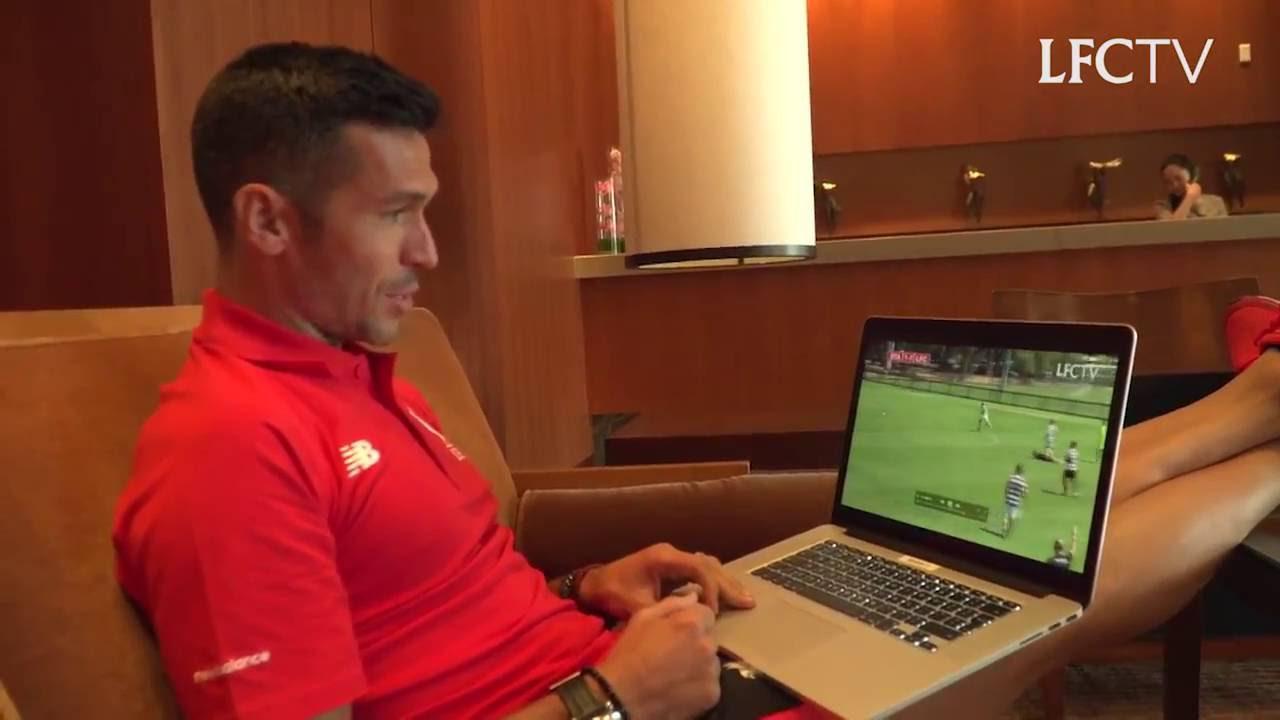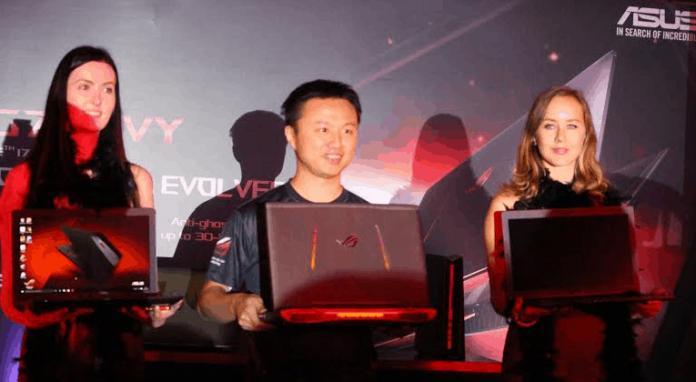The first image is the image on the left, the second image is the image on the right. Considering the images on both sides, is "In the image to the left, we can see exactly one guy; his upper body and face are quite visible and are obvious targets of the image." valid? Answer yes or no. Yes. The first image is the image on the left, the second image is the image on the right. Considering the images on both sides, is "An image shows one man looking at an open laptop witth his feet propped up." valid? Answer yes or no. Yes. 